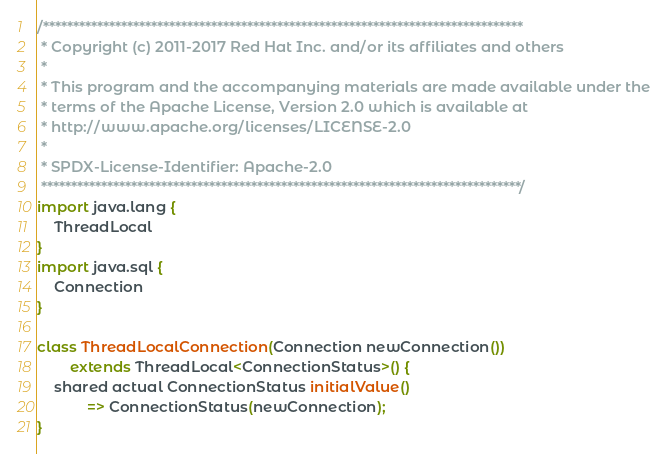<code> <loc_0><loc_0><loc_500><loc_500><_Ceylon_>/********************************************************************************
 * Copyright (c) 2011-2017 Red Hat Inc. and/or its affiliates and others
 *
 * This program and the accompanying materials are made available under the 
 * terms of the Apache License, Version 2.0 which is available at
 * http://www.apache.org/licenses/LICENSE-2.0
 *
 * SPDX-License-Identifier: Apache-2.0 
 ********************************************************************************/
import java.lang {
    ThreadLocal
}
import java.sql {
    Connection
}

class ThreadLocalConnection(Connection newConnection()) 
        extends ThreadLocal<ConnectionStatus>() {
    shared actual ConnectionStatus initialValue()
            => ConnectionStatus(newConnection);
}
</code> 